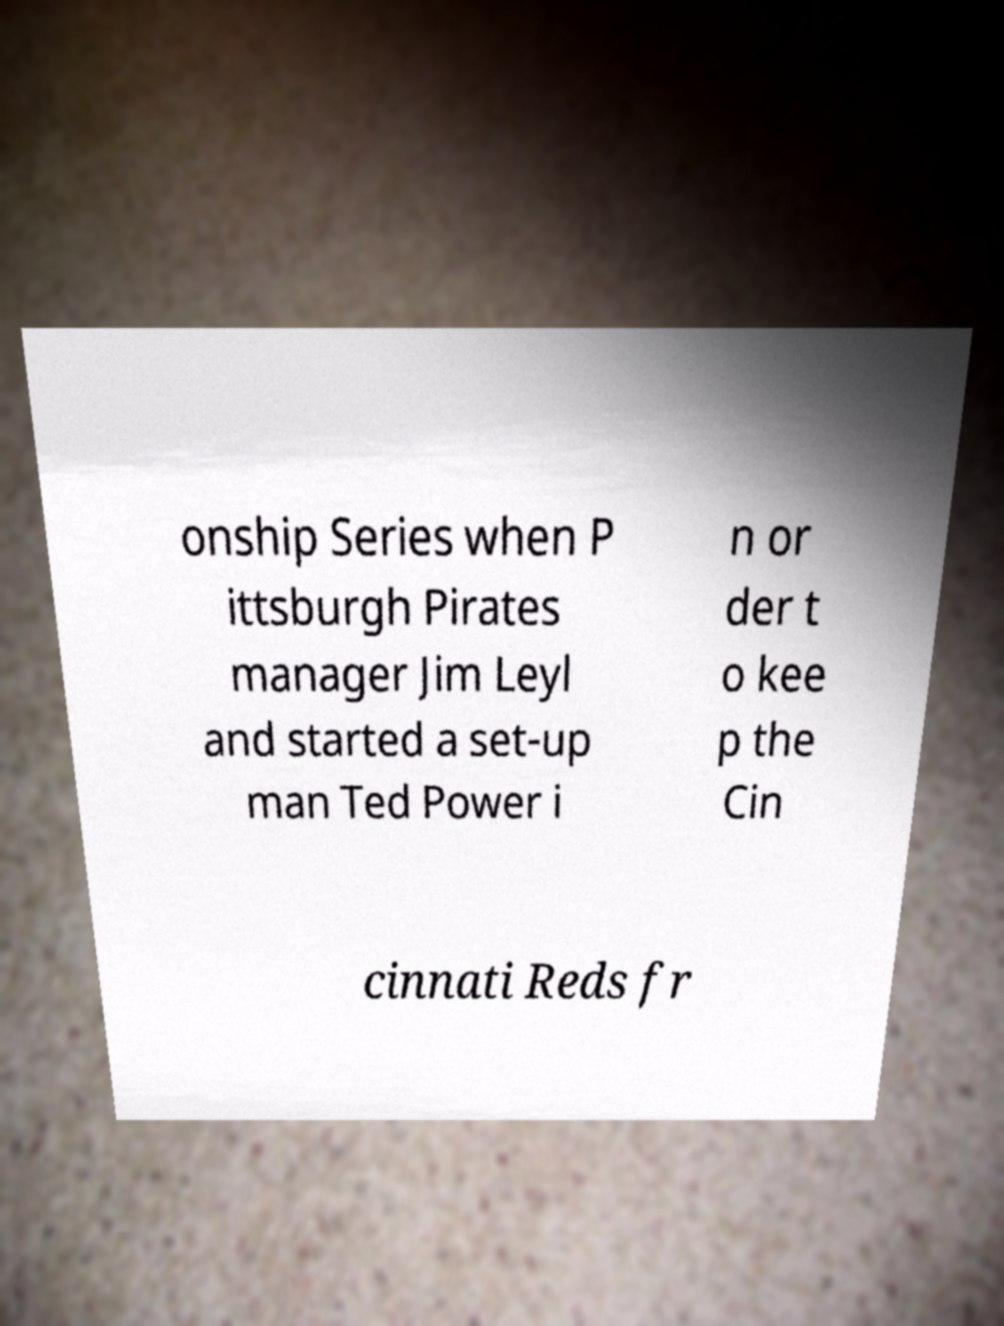I need the written content from this picture converted into text. Can you do that? onship Series when P ittsburgh Pirates manager Jim Leyl and started a set-up man Ted Power i n or der t o kee p the Cin cinnati Reds fr 